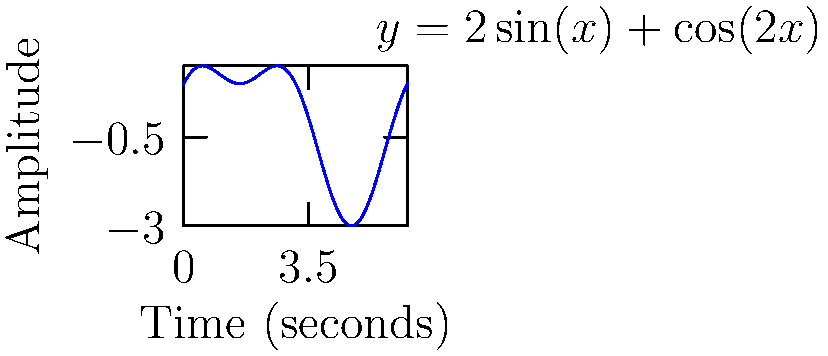During a 30-minute music therapy session, the auditory input a non-verbal child receives is represented by the waveform $y = 2\sin(x) + \cos(2x)$, where $x$ is time in seconds and $y$ is the amplitude of the sound. Calculate the total auditory input the child receives over the entire session by finding the area under the curve. Round your answer to two decimal places. To solve this problem, we need to follow these steps:

1) The total auditory input is represented by the area under the curve, which can be calculated using a definite integral.

2) The function is $f(x) = 2\sin(x) + \cos(2x)$.

3) The session lasts for 30 minutes, which is 1800 seconds. So we need to integrate from 0 to 1800.

4) Set up the integral:

   $$\int_0^{1800} (2\sin(x) + \cos(2x)) dx$$

5) To solve this, we can use the fundamental theorem of calculus:

   $$[-2\cos(x) + \frac{1}{2}\sin(2x)]_0^{1800}$$

6) Evaluate at the upper and lower bounds:

   $$[-2\cos(1800) + \frac{1}{2}\sin(3600)] - [-2\cos(0) + \frac{1}{2}\sin(0)]$$

7) Simplify:

   $$[-2\cos(1800) + \frac{1}{2}\sin(3600)] - [-2 + 0]$$

8) Calculate:

   $$[-2(-0.9880) + \frac{1}{2}(-0.2768)] - (-2)$$

   $$[1.9760 - 0.1384] + 2$$

   $$3.8376$$

9) Round to two decimal places: 3.84
Answer: 3.84 